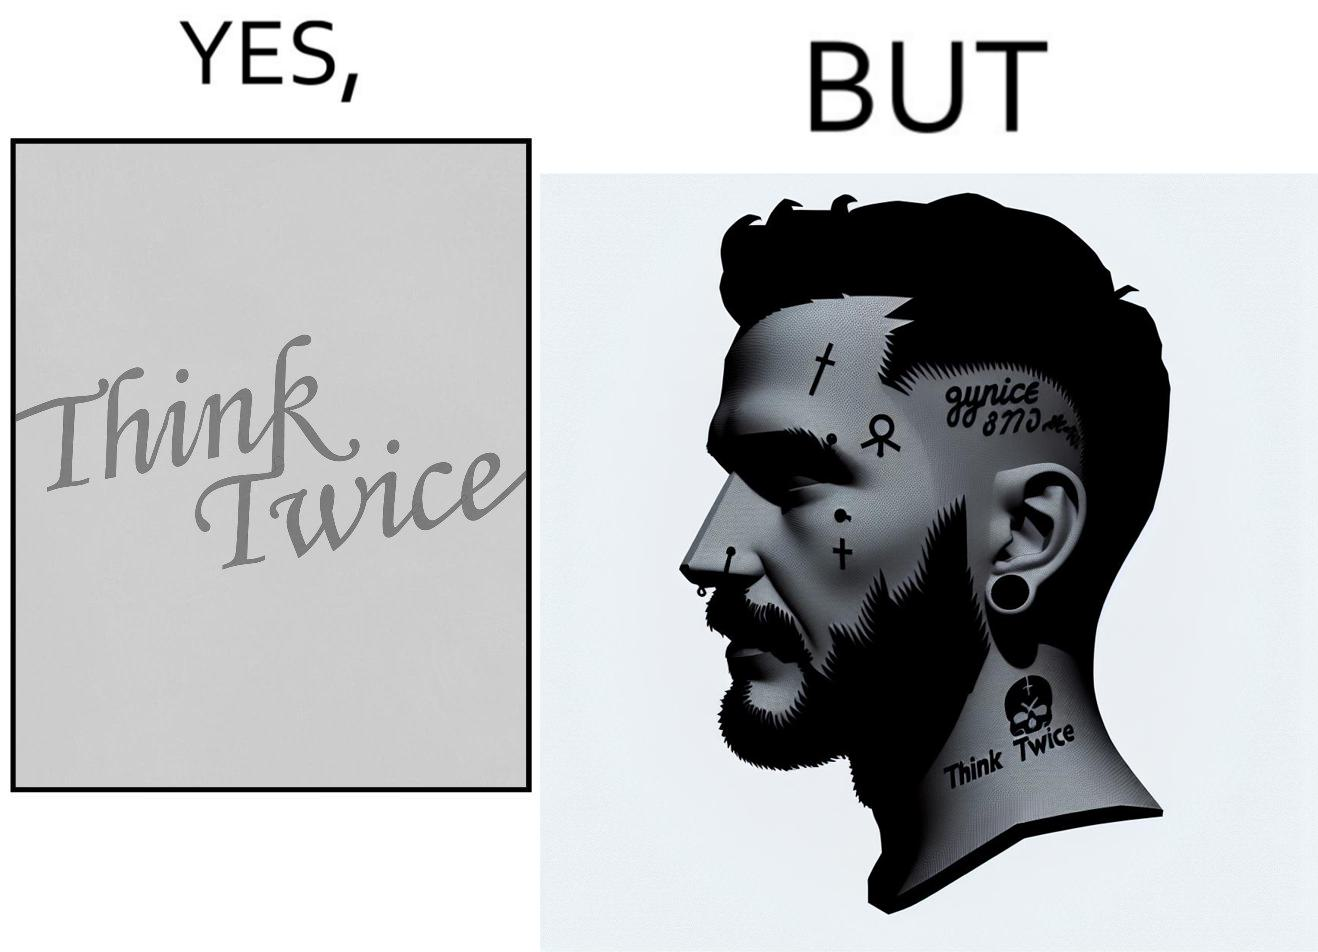Describe the contrast between the left and right parts of this image. In the left part of the image: The image shows a text in english saying "Think Twice". The font seems very fashionable. In the right part of the image: The image shows the face of a man with a tattoo on the left side of a forehead saying "Think Twice". The man is wearing a nose ring and has a cut on his left eyebrow. He also has a small tattoo of the cross a little below his left eye. 